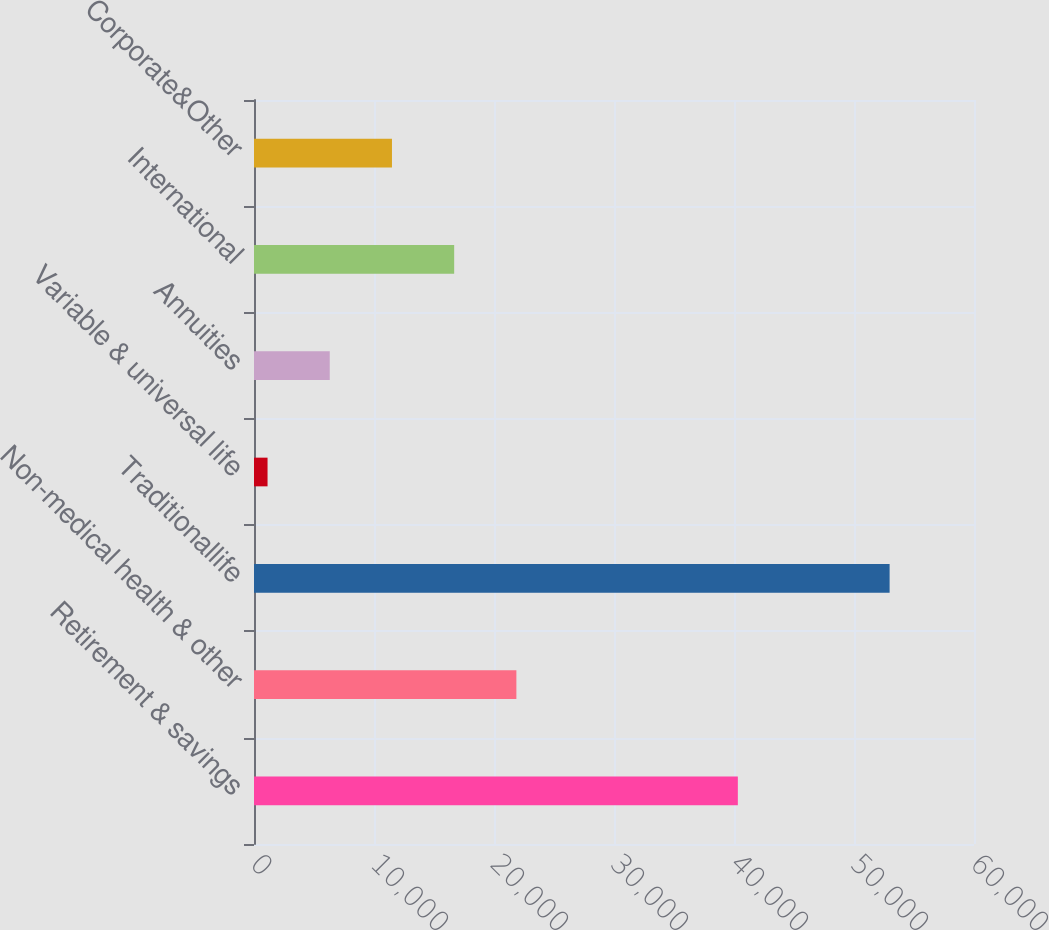Convert chart. <chart><loc_0><loc_0><loc_500><loc_500><bar_chart><fcel>Retirement & savings<fcel>Non-medical health & other<fcel>Traditionallife<fcel>Variable & universal life<fcel>Annuities<fcel>International<fcel>Corporate&Other<nl><fcel>40320<fcel>21864.6<fcel>52968<fcel>1129<fcel>6312.9<fcel>16680.7<fcel>11496.8<nl></chart> 